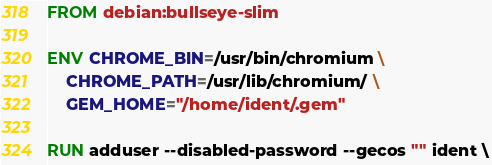Convert code to text. <code><loc_0><loc_0><loc_500><loc_500><_Dockerfile_>FROM debian:bullseye-slim

ENV CHROME_BIN=/usr/bin/chromium \
    CHROME_PATH=/usr/lib/chromium/ \
    GEM_HOME="/home/ident/.gem"

RUN adduser --disabled-password --gecos "" ident \</code> 